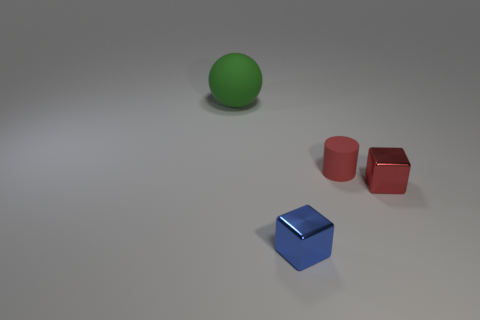There is a metallic object that is the same color as the tiny matte cylinder; what size is it?
Your answer should be very brief. Small. Is there another block that has the same material as the small blue cube?
Your response must be concise. Yes. Are there more tiny red blocks than large yellow objects?
Give a very brief answer. Yes. Are the tiny blue cube and the big thing made of the same material?
Your response must be concise. No. How many metal things are red things or blue cubes?
Give a very brief answer. 2. There is a cylinder that is the same size as the blue object; what is its color?
Your answer should be compact. Red. What number of other metal things are the same shape as the red metal object?
Your response must be concise. 1. How many spheres are either green objects or metal things?
Make the answer very short. 1. There is a matte object that is in front of the big thing; is its shape the same as the metallic thing that is right of the blue thing?
Keep it short and to the point. No. What is the blue block made of?
Your answer should be very brief. Metal. 